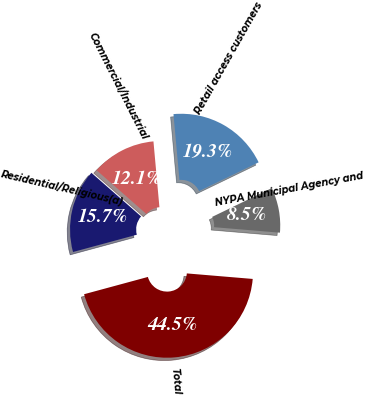Convert chart. <chart><loc_0><loc_0><loc_500><loc_500><pie_chart><fcel>Residential/Religious(a)<fcel>Commercial/Industrial<fcel>Retail access customers<fcel>NYPA Municipal Agency and<fcel>Total<nl><fcel>15.68%<fcel>12.09%<fcel>19.28%<fcel>8.49%<fcel>44.46%<nl></chart> 